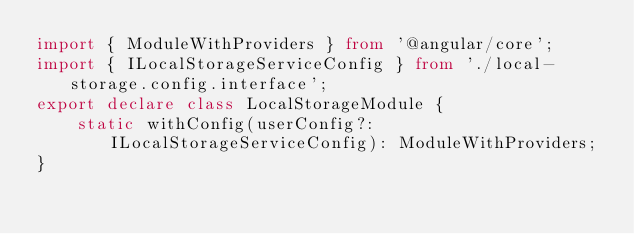Convert code to text. <code><loc_0><loc_0><loc_500><loc_500><_TypeScript_>import { ModuleWithProviders } from '@angular/core';
import { ILocalStorageServiceConfig } from './local-storage.config.interface';
export declare class LocalStorageModule {
    static withConfig(userConfig?: ILocalStorageServiceConfig): ModuleWithProviders;
}
</code> 